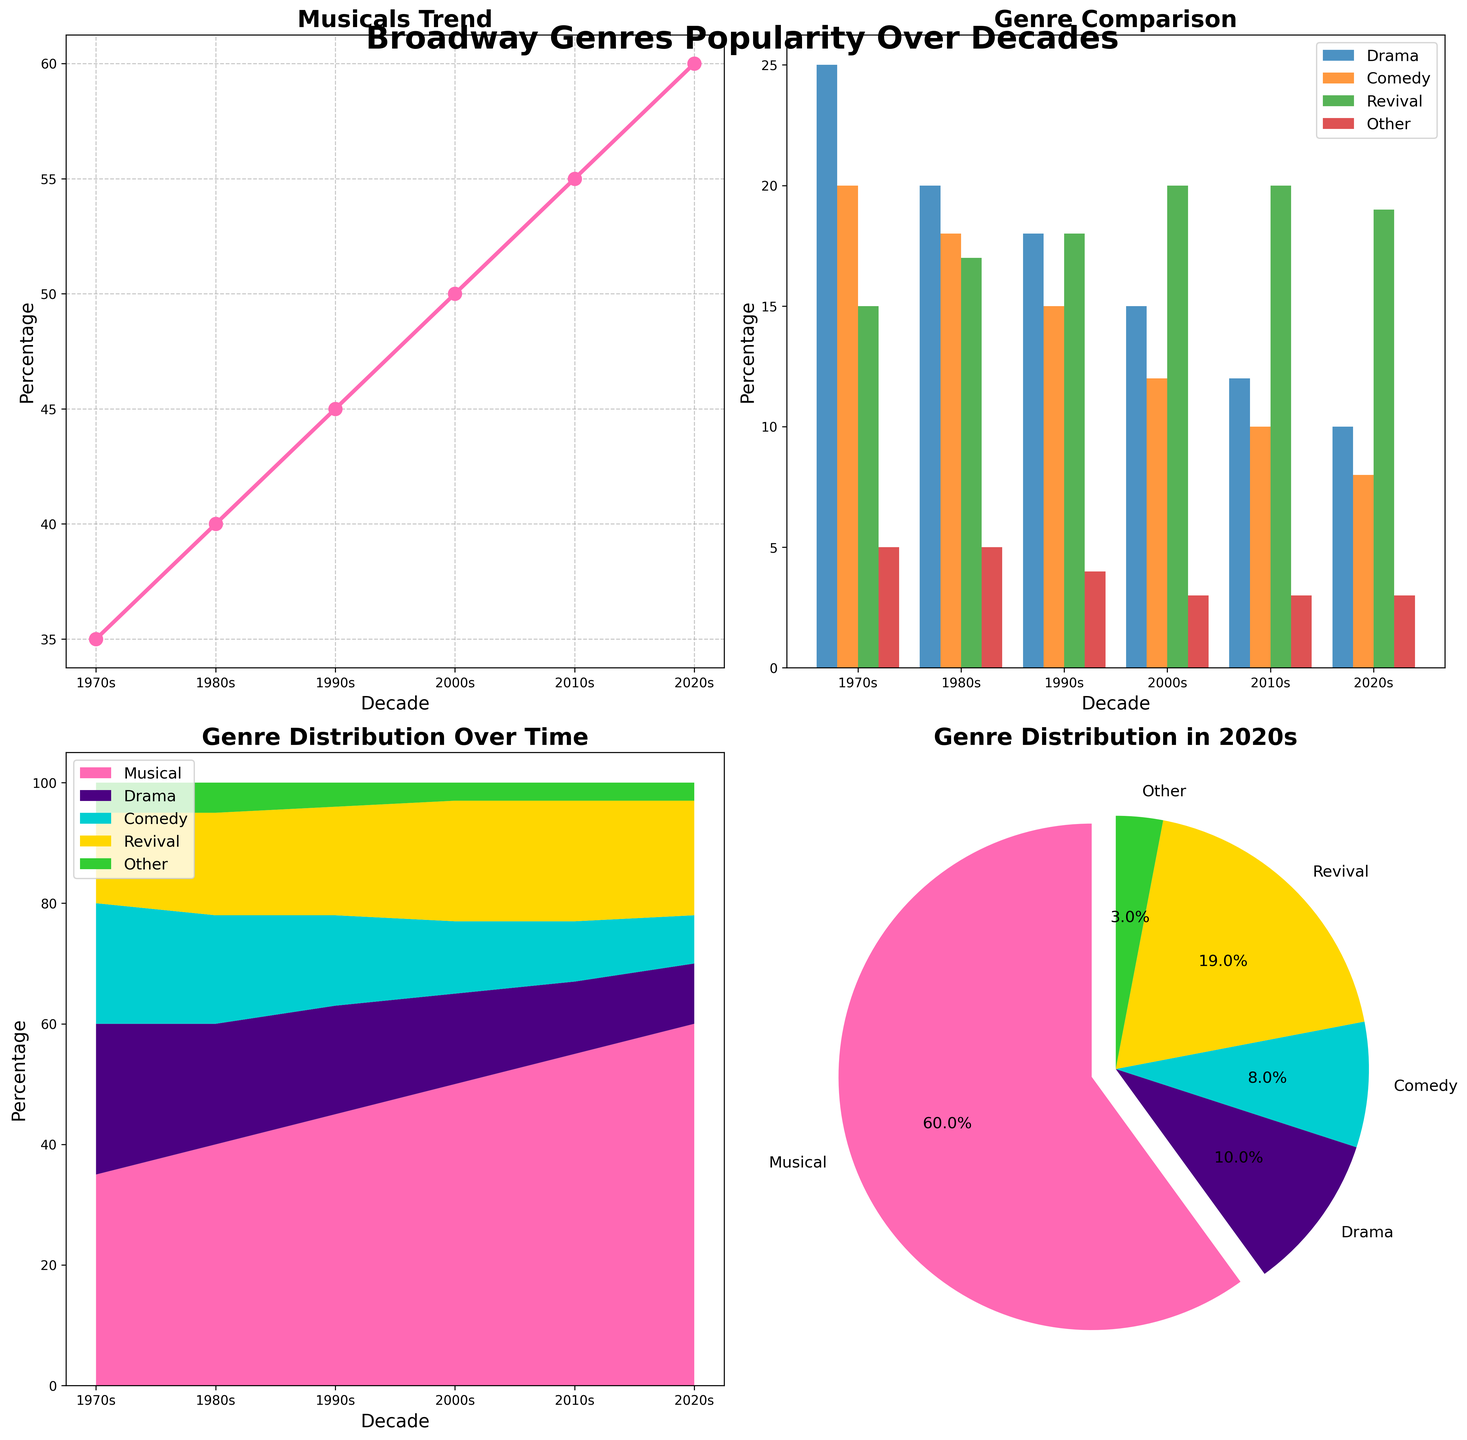what is the title of the entire figure? The title of the entire figure is displayed prominently at the top of the plot. You can find it labeled as "Broadway Genres Popularity Over Decades" in bold and larger font size.
Answer: Broadway Genres Popularity Over Decades What kind of plot shows the trend of Musicals over time? The plot showing the trend of Musicals over time is a line plot. It is located in the top-left corner and titled "Musicals Trend."
Answer: line plot Which genre had the highest percentage in the 2020s according to the pie chart? The pie chart shows the genre distribution for the 2020s. The Musical genre slices the largest section of the pie chart.
Answer: Musical Which subplot compares the percentages of Drama, Comedy, Revival, and Other genres across decades? The subplot comparing the percentages of Drama, Comedy, Revival, and Other genres is the bar plot located in the top-right corner of the figure and titled "Genre Comparison."
Answer: bar plot What is the overall trend of the Musical genre from the 1970s to the 2020s? The line plot in the top-left corner illustrates the trend. The percentage of the Musical genre continually increases from the 1970s (35%) to the 2020s (60%).
Answer: Increasing In the stacked area plot, which decades saw the most growth in the Drama genre? Examining the stacked area plot in the bottom-left corner, the Drama genre saw the richest color segment between the 1970s and 1980s. After that, the percentage of Drama decreases.
Answer: 1970s to 1980s Which two genres together make up less than 10% in the 2020s? Refer to the pie chart in the bottom-right corner. The Comedy genre (8%) and the Other genre (3%) combined are less than 10%.
Answer: Drama, Other How does the percentage of Comedy change from the 1970s to the 2020s? In the bar plot (top-right) and stacked area plot (bottom-left), you can see that the percentage of Comedy decreases from 20% in the 1970s to 8% in the 2020s, declining over the decades.
Answer: Decreasing What is the decade with the highest percentage of the Revival genre in the ‘Genre Comparison’ plot? In the bar plot titled 'Genre Comparison', the decade with the highest percentage of the Revival genre is the 2010s with 20%.
Answer: 2010s In which subplot can you find the exact percentage values for each genre in the 2020s? The pie chart located in the bottom-right corner shows the exact percentage values of each genre for the 2020s, with labels and percentages clearly marked.
Answer: pie chart 